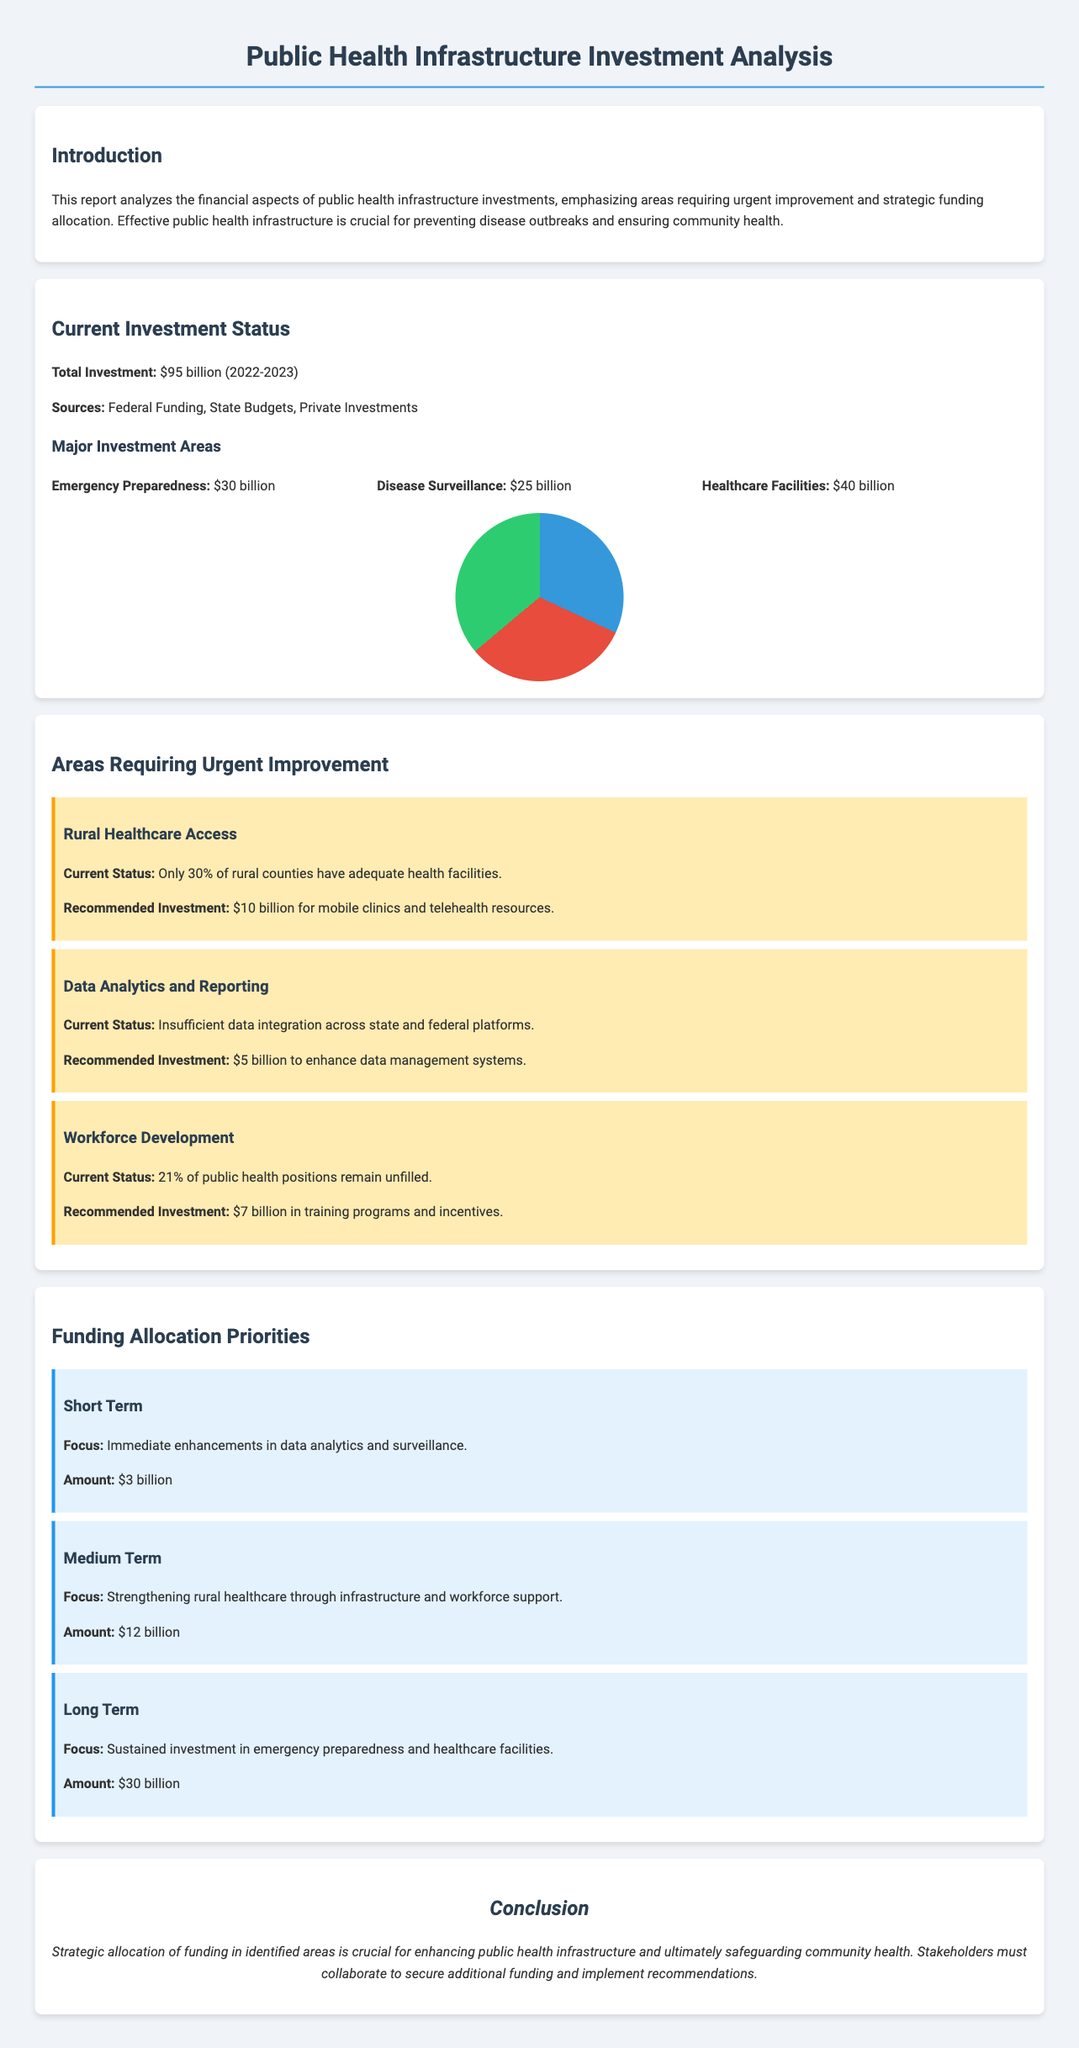What is the total investment for public health infrastructure? The total investment figure is specified in the document as $95 billion for the period of 2022-2023.
Answer: $95 billion What area received the highest investment? The document provides a breakdown of investments, and healthcare facilities received the highest amount at $40 billion.
Answer: Healthcare Facilities: $40 billion How much is recommended for improving rural healthcare access? The report lists a specific recommendation for rural healthcare access, which highlights an investment of $10 billion for mobile clinics and telehealth resources.
Answer: $10 billion What percentage of public health positions remain unfilled? The document states that 21% of public health positions are currently unfilled, indicating workforce challenges.
Answer: 21% What is the focus of the medium-term funding priority? The document outlines the medium-term focus as strengthening rural healthcare through infrastructure and workforce support.
Answer: Strengthening rural healthcare What amount is suggested for immediate enhancements in data analytics? The short-term funding priority specifies an amount of $3 billion designated for immediate enhancements in data analytics and surveillance.
Answer: $3 billion What issue does the data analytics and reporting section highlight? The document mentions the insufficient data integration across state and federal platforms as a significant issue needing attention.
Answer: Insufficient data integration How much funding is recommended for workforce development? The report clearly states a need for $7 billion in training programs and incentives to support workforce development.
Answer: $7 billion What are the three identified funding allocation priorities? The document categorizes funding allocation into short term, medium term, and long term as its main priorities.
Answer: Short Term, Medium Term, Long Term 